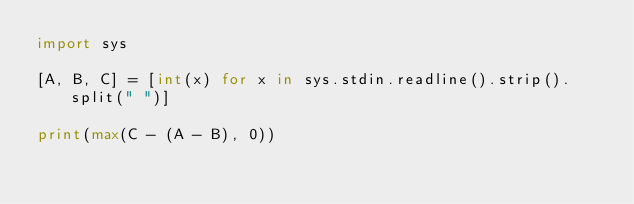Convert code to text. <code><loc_0><loc_0><loc_500><loc_500><_Python_>import sys

[A, B, C] = [int(x) for x in sys.stdin.readline().strip().split(" ")]

print(max(C - (A - B), 0))
</code> 